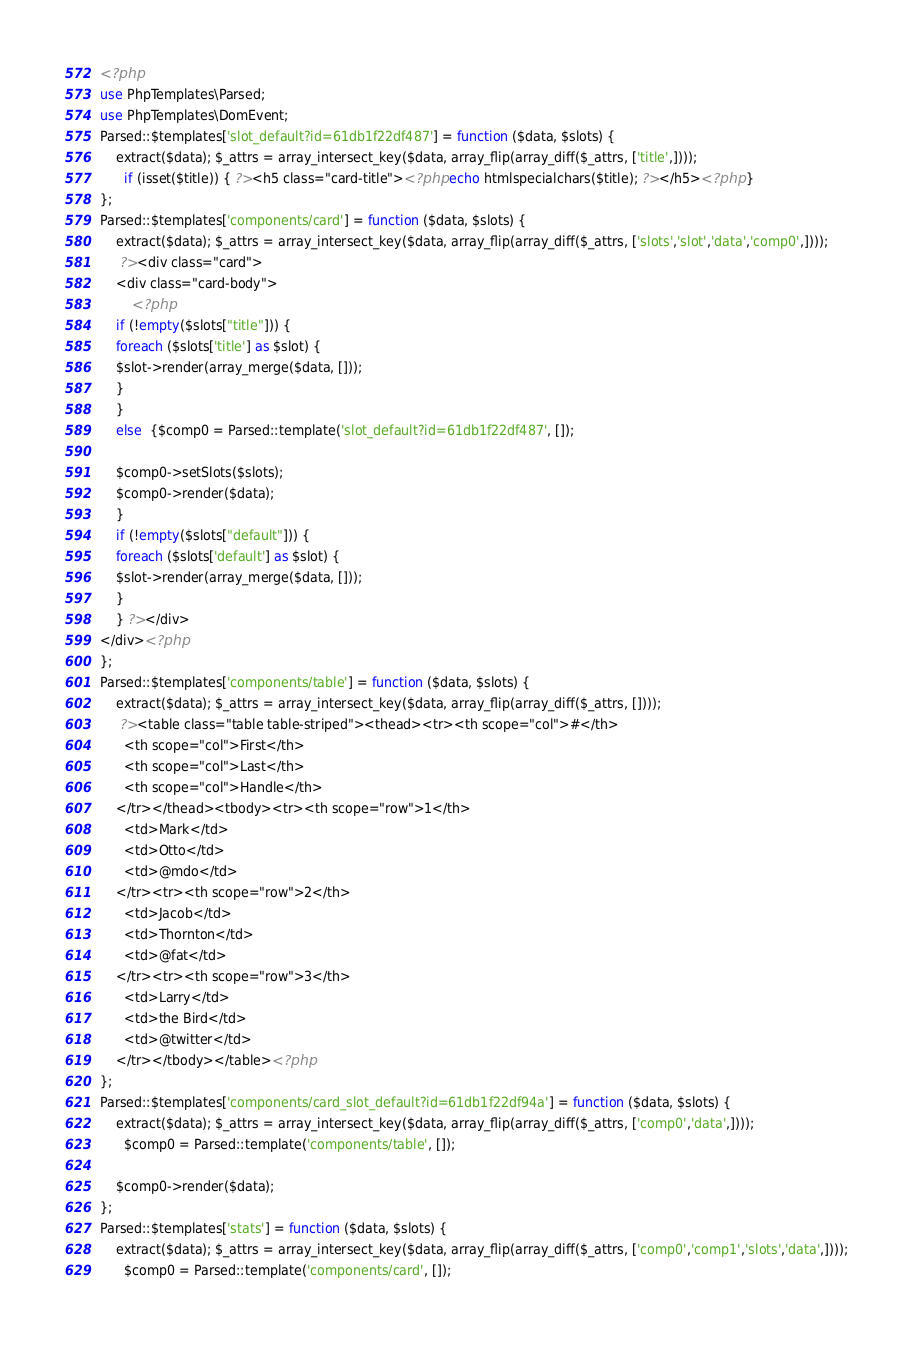<code> <loc_0><loc_0><loc_500><loc_500><_PHP_><?php 
use PhpTemplates\Parsed;
use PhpTemplates\DomEvent;
Parsed::$templates['slot_default?id=61db1f22df487'] = function ($data, $slots) {
    extract($data); $_attrs = array_intersect_key($data, array_flip(array_diff($_attrs, ['title',])));
      if (isset($title)) { ?><h5 class="card-title"><?php echo htmlspecialchars($title); ?></h5><?php }  
};
Parsed::$templates['components/card'] = function ($data, $slots) {
    extract($data); $_attrs = array_intersect_key($data, array_flip(array_diff($_attrs, ['slots','slot','data','comp0',])));
     ?><div class="card">
    <div class="card-body">
        <?php 
    if (!empty($slots["title"])) {
    foreach ($slots['title'] as $slot) {
    $slot->render(array_merge($data, []));
    }
    }
    else  {$comp0 = Parsed::template('slot_default?id=61db1f22df487', []);

    $comp0->setSlots($slots);
    $comp0->render($data);
    }  
    if (!empty($slots["default"])) {
    foreach ($slots['default'] as $slot) {
    $slot->render(array_merge($data, []));
    }
    } ?></div>
</div><?php 
};
Parsed::$templates['components/table'] = function ($data, $slots) {
    extract($data); $_attrs = array_intersect_key($data, array_flip(array_diff($_attrs, [])));
     ?><table class="table table-striped"><thead><tr><th scope="col">#</th>
      <th scope="col">First</th>
      <th scope="col">Last</th>
      <th scope="col">Handle</th>
    </tr></thead><tbody><tr><th scope="row">1</th>
      <td>Mark</td>
      <td>Otto</td>
      <td>@mdo</td>
    </tr><tr><th scope="row">2</th>
      <td>Jacob</td>
      <td>Thornton</td>
      <td>@fat</td>
    </tr><tr><th scope="row">3</th>
      <td>Larry</td>
      <td>the Bird</td>
      <td>@twitter</td>
    </tr></tbody></table><?php 
};
Parsed::$templates['components/card_slot_default?id=61db1f22df94a'] = function ($data, $slots) {
    extract($data); $_attrs = array_intersect_key($data, array_flip(array_diff($_attrs, ['comp0','data',])));
      $comp0 = Parsed::template('components/table', []);

    $comp0->render($data);  
};
Parsed::$templates['stats'] = function ($data, $slots) {
    extract($data); $_attrs = array_intersect_key($data, array_flip(array_diff($_attrs, ['comp0','comp1','slots','data',])));
      $comp0 = Parsed::template('components/card', []);</code> 